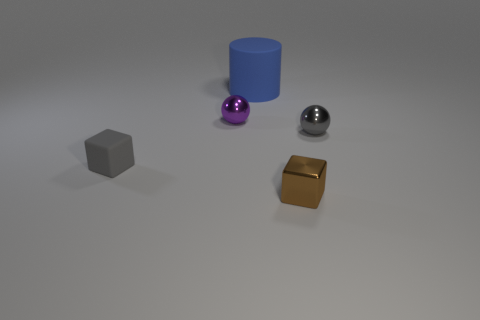Are there the same number of matte things behind the tiny gray metallic ball and tiny blocks? No, there aren't an equal number of matte objects behind each item. If we observe carefully, there are two matte objects behind the small metallic ball, which are the gray cube and the blue cylinder. Behind the golden cube, there is only one matte object, the purple sphere. 